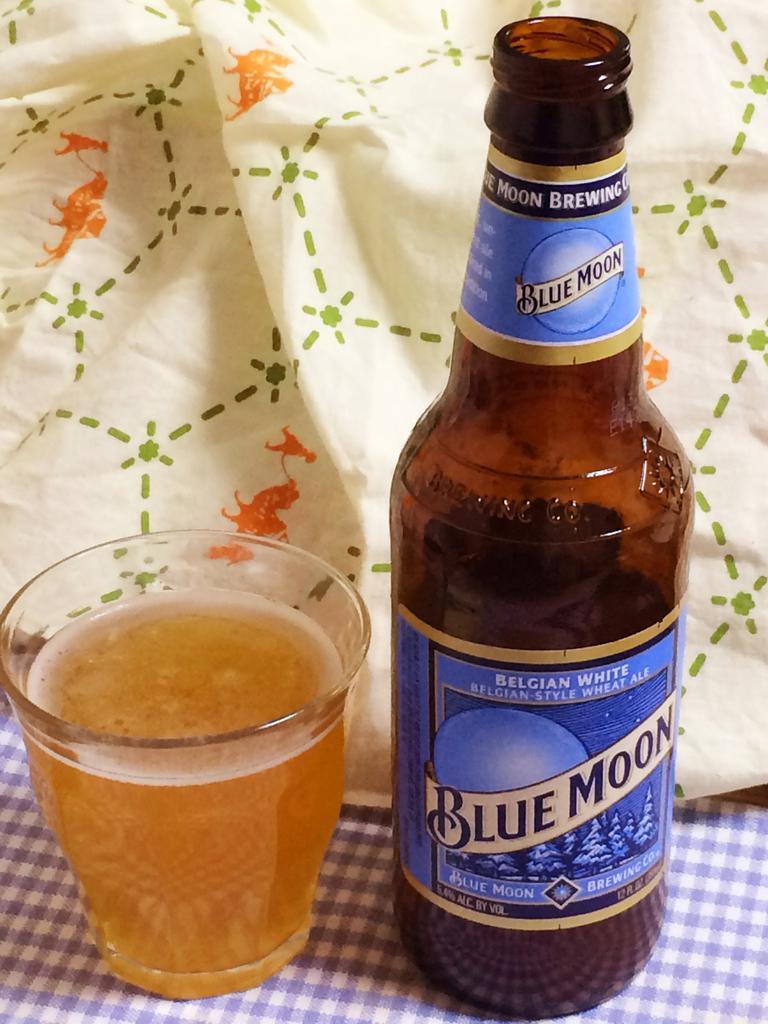Describe this image in one or two sentences. In the image we can see there is a beer bottle and beside it there is a glass filled with beer in it kept on the table cloth. 